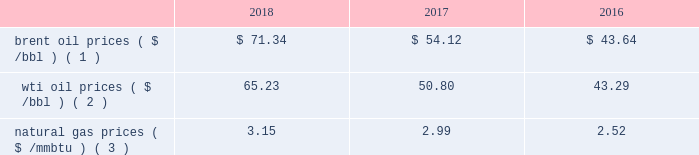Bhge 2018 form 10-k | 31 business environment the following discussion and analysis summarizes the significant factors affecting our results of operations , financial condition and liquidity position as of and for the year ended december 31 , 2018 , 2017 and 2016 , and should be read in conjunction with the consolidated and combined financial statements and related notes of the company .
We operate in more than 120 countries helping customers find , evaluate , drill , produce , transport and process hydrocarbon resources .
Our revenue is predominately generated from the sale of products and services to major , national , and independent oil and natural gas companies worldwide , and is dependent on spending by our customers for oil and natural gas exploration , field development and production .
This spending is driven by a number of factors , including our customers' forecasts of future energy demand and supply , their access to resources to develop and produce oil and natural gas , their ability to fund their capital programs , the impact of new government regulations and most importantly , their expectations for oil and natural gas prices as a key driver of their cash flows .
Oil and natural gas prices oil and natural gas prices are summarized in the table below as averages of the daily closing prices during each of the periods indicated. .
Brent oil prices ( $ /bbl ) ( 1 ) $ 71.34 $ 54.12 $ 43.64 wti oil prices ( $ /bbl ) ( 2 ) 65.23 50.80 43.29 natural gas prices ( $ /mmbtu ) ( 3 ) 3.15 2.99 2.52 ( 1 ) energy information administration ( eia ) europe brent spot price per barrel ( 2 ) eia cushing , ok wti ( west texas intermediate ) spot price ( 3 ) eia henry hub natural gas spot price per million british thermal unit 2018 demonstrated the volatility of the oil and gas market .
Through the first three quarters of 2018 , we experienced stability in the north american and international markets .
However , in the fourth quarter of 2018 commodity prices dropped nearly 40% ( 40 % ) resulting in increased customer uncertainty .
From an offshore standpoint , through most of 2018 , we saw multiple large offshore projects reach positive final investment decisions , and the lng market and outlook improved throughout 2018 , driven by increased demand globally .
In 2018 , the first large north american lng positive final investment decision was reached .
Outside of north america , customer spending is highly driven by brent oil prices , which increased on average throughout the year .
Average brent oil prices increased to $ 71.34/bbl in 2018 from $ 54.12/bbl in 2017 , and ranged from a low of $ 50.57/bbl in december 2018 , to a high of $ 86.07/bbl in october 2018 .
For the first three quarters of 2018 , brent oil prices increased sequentially .
However , in the fourth quarter , brent oil prices declined 39% ( 39 % ) versus the end of the third quarter , as a result of increased supply from the u.s. , worries of a global economic slowdown , and lower than expected production cuts .
In north america , customer spending is highly driven by wti oil prices , which similar to brent oil prices , on average increased throughout the year .
Average wti oil prices increased to $ 65.23/bbl in 2018 from $ 50.80/bbl in 2017 , and ranged from a low of $ 44.48/bbl in december 2018 , to a high of $ 77.41/bbl in june 2018 .
In north america , natural gas prices , as measured by the henry hub natural gas spot price , averaged $ 3.15/ mmbtu in 2018 , representing a 6% ( 6 % ) increase over the prior year .
Throughout the year , henry hub natural gas spot prices ranged from a high of $ 6.24/mmbtu in january 2018 to a low of $ 2.49/mmbtu in february 2018 .
According to the u.s .
Department of energy ( doe ) , working natural gas in storage at the end of 2018 was 2705 billion cubic feet ( bcf ) , which was 15.6% ( 15.6 % ) , or 421 bcf , below the corresponding week in 2017. .
What is the growth rate in brent oil prices from 2017 to 2018? 
Computations: ((71.34 - 54.12) / 54.12)
Answer: 0.31818. 